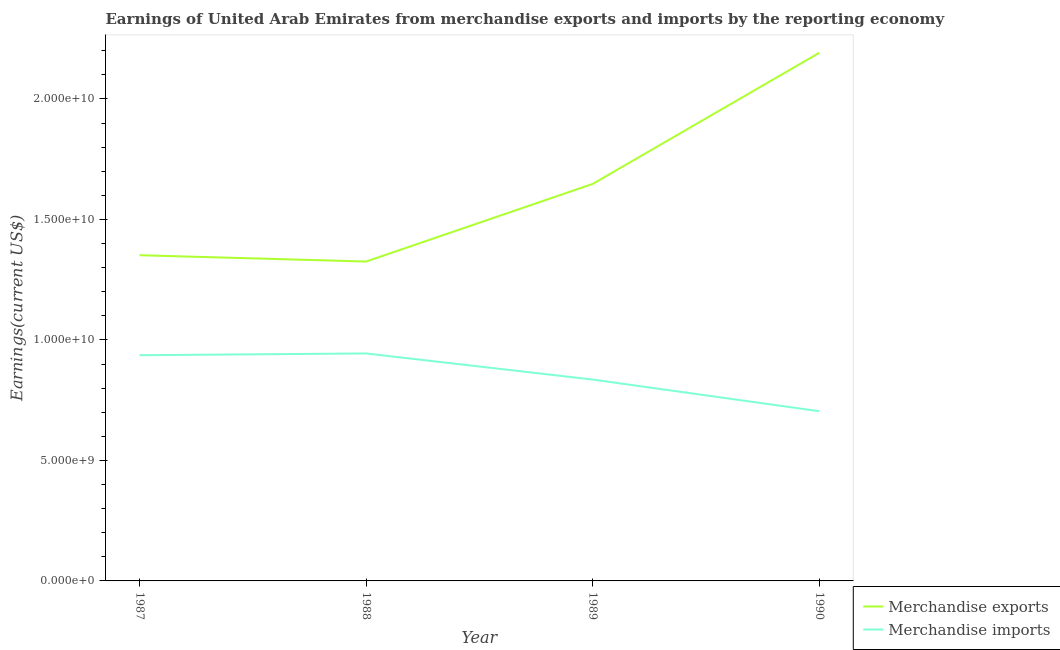Does the line corresponding to earnings from merchandise imports intersect with the line corresponding to earnings from merchandise exports?
Ensure brevity in your answer.  No. What is the earnings from merchandise imports in 1988?
Give a very brief answer. 9.44e+09. Across all years, what is the maximum earnings from merchandise imports?
Offer a very short reply. 9.44e+09. Across all years, what is the minimum earnings from merchandise imports?
Your response must be concise. 7.04e+09. In which year was the earnings from merchandise exports maximum?
Your answer should be compact. 1990. What is the total earnings from merchandise imports in the graph?
Offer a terse response. 3.42e+1. What is the difference between the earnings from merchandise imports in 1987 and that in 1988?
Give a very brief answer. -7.33e+07. What is the difference between the earnings from merchandise exports in 1988 and the earnings from merchandise imports in 1990?
Provide a succinct answer. 6.21e+09. What is the average earnings from merchandise imports per year?
Offer a very short reply. 8.55e+09. In the year 1987, what is the difference between the earnings from merchandise exports and earnings from merchandise imports?
Your answer should be compact. 4.15e+09. In how many years, is the earnings from merchandise exports greater than 9000000000 US$?
Your answer should be compact. 4. What is the ratio of the earnings from merchandise exports in 1987 to that in 1988?
Ensure brevity in your answer.  1.02. Is the difference between the earnings from merchandise exports in 1987 and 1989 greater than the difference between the earnings from merchandise imports in 1987 and 1989?
Offer a very short reply. No. What is the difference between the highest and the second highest earnings from merchandise exports?
Keep it short and to the point. 5.44e+09. What is the difference between the highest and the lowest earnings from merchandise imports?
Give a very brief answer. 2.40e+09. In how many years, is the earnings from merchandise imports greater than the average earnings from merchandise imports taken over all years?
Your answer should be very brief. 2. Does the earnings from merchandise exports monotonically increase over the years?
Offer a very short reply. No. How many lines are there?
Your answer should be very brief. 2. How many years are there in the graph?
Offer a very short reply. 4. Are the values on the major ticks of Y-axis written in scientific E-notation?
Provide a short and direct response. Yes. Does the graph contain grids?
Keep it short and to the point. No. How are the legend labels stacked?
Provide a short and direct response. Vertical. What is the title of the graph?
Make the answer very short. Earnings of United Arab Emirates from merchandise exports and imports by the reporting economy. Does "Borrowers" appear as one of the legend labels in the graph?
Offer a very short reply. No. What is the label or title of the Y-axis?
Ensure brevity in your answer.  Earnings(current US$). What is the Earnings(current US$) of Merchandise exports in 1987?
Ensure brevity in your answer.  1.35e+1. What is the Earnings(current US$) of Merchandise imports in 1987?
Your response must be concise. 9.37e+09. What is the Earnings(current US$) of Merchandise exports in 1988?
Make the answer very short. 1.33e+1. What is the Earnings(current US$) in Merchandise imports in 1988?
Provide a short and direct response. 9.44e+09. What is the Earnings(current US$) in Merchandise exports in 1989?
Provide a short and direct response. 1.65e+1. What is the Earnings(current US$) of Merchandise imports in 1989?
Offer a very short reply. 8.36e+09. What is the Earnings(current US$) of Merchandise exports in 1990?
Make the answer very short. 2.19e+1. What is the Earnings(current US$) in Merchandise imports in 1990?
Ensure brevity in your answer.  7.04e+09. Across all years, what is the maximum Earnings(current US$) in Merchandise exports?
Provide a short and direct response. 2.19e+1. Across all years, what is the maximum Earnings(current US$) of Merchandise imports?
Your response must be concise. 9.44e+09. Across all years, what is the minimum Earnings(current US$) of Merchandise exports?
Keep it short and to the point. 1.33e+1. Across all years, what is the minimum Earnings(current US$) in Merchandise imports?
Offer a very short reply. 7.04e+09. What is the total Earnings(current US$) in Merchandise exports in the graph?
Your answer should be very brief. 6.52e+1. What is the total Earnings(current US$) of Merchandise imports in the graph?
Make the answer very short. 3.42e+1. What is the difference between the Earnings(current US$) of Merchandise exports in 1987 and that in 1988?
Ensure brevity in your answer.  2.62e+08. What is the difference between the Earnings(current US$) in Merchandise imports in 1987 and that in 1988?
Give a very brief answer. -7.33e+07. What is the difference between the Earnings(current US$) of Merchandise exports in 1987 and that in 1989?
Your answer should be very brief. -2.96e+09. What is the difference between the Earnings(current US$) of Merchandise imports in 1987 and that in 1989?
Ensure brevity in your answer.  1.01e+09. What is the difference between the Earnings(current US$) of Merchandise exports in 1987 and that in 1990?
Your answer should be very brief. -8.40e+09. What is the difference between the Earnings(current US$) in Merchandise imports in 1987 and that in 1990?
Offer a very short reply. 2.32e+09. What is the difference between the Earnings(current US$) in Merchandise exports in 1988 and that in 1989?
Make the answer very short. -3.22e+09. What is the difference between the Earnings(current US$) of Merchandise imports in 1988 and that in 1989?
Keep it short and to the point. 1.08e+09. What is the difference between the Earnings(current US$) of Merchandise exports in 1988 and that in 1990?
Offer a terse response. -8.66e+09. What is the difference between the Earnings(current US$) of Merchandise imports in 1988 and that in 1990?
Provide a short and direct response. 2.40e+09. What is the difference between the Earnings(current US$) in Merchandise exports in 1989 and that in 1990?
Provide a succinct answer. -5.44e+09. What is the difference between the Earnings(current US$) of Merchandise imports in 1989 and that in 1990?
Offer a very short reply. 1.31e+09. What is the difference between the Earnings(current US$) in Merchandise exports in 1987 and the Earnings(current US$) in Merchandise imports in 1988?
Offer a terse response. 4.08e+09. What is the difference between the Earnings(current US$) of Merchandise exports in 1987 and the Earnings(current US$) of Merchandise imports in 1989?
Keep it short and to the point. 5.16e+09. What is the difference between the Earnings(current US$) of Merchandise exports in 1987 and the Earnings(current US$) of Merchandise imports in 1990?
Your answer should be very brief. 6.47e+09. What is the difference between the Earnings(current US$) in Merchandise exports in 1988 and the Earnings(current US$) in Merchandise imports in 1989?
Ensure brevity in your answer.  4.90e+09. What is the difference between the Earnings(current US$) in Merchandise exports in 1988 and the Earnings(current US$) in Merchandise imports in 1990?
Make the answer very short. 6.21e+09. What is the difference between the Earnings(current US$) in Merchandise exports in 1989 and the Earnings(current US$) in Merchandise imports in 1990?
Your answer should be very brief. 9.43e+09. What is the average Earnings(current US$) of Merchandise exports per year?
Your answer should be very brief. 1.63e+1. What is the average Earnings(current US$) of Merchandise imports per year?
Provide a succinct answer. 8.55e+09. In the year 1987, what is the difference between the Earnings(current US$) in Merchandise exports and Earnings(current US$) in Merchandise imports?
Your answer should be compact. 4.15e+09. In the year 1988, what is the difference between the Earnings(current US$) of Merchandise exports and Earnings(current US$) of Merchandise imports?
Your answer should be compact. 3.82e+09. In the year 1989, what is the difference between the Earnings(current US$) of Merchandise exports and Earnings(current US$) of Merchandise imports?
Ensure brevity in your answer.  8.12e+09. In the year 1990, what is the difference between the Earnings(current US$) in Merchandise exports and Earnings(current US$) in Merchandise imports?
Make the answer very short. 1.49e+1. What is the ratio of the Earnings(current US$) in Merchandise exports in 1987 to that in 1988?
Keep it short and to the point. 1.02. What is the ratio of the Earnings(current US$) of Merchandise exports in 1987 to that in 1989?
Give a very brief answer. 0.82. What is the ratio of the Earnings(current US$) of Merchandise imports in 1987 to that in 1989?
Keep it short and to the point. 1.12. What is the ratio of the Earnings(current US$) in Merchandise exports in 1987 to that in 1990?
Make the answer very short. 0.62. What is the ratio of the Earnings(current US$) of Merchandise imports in 1987 to that in 1990?
Provide a succinct answer. 1.33. What is the ratio of the Earnings(current US$) of Merchandise exports in 1988 to that in 1989?
Make the answer very short. 0.8. What is the ratio of the Earnings(current US$) of Merchandise imports in 1988 to that in 1989?
Provide a short and direct response. 1.13. What is the ratio of the Earnings(current US$) in Merchandise exports in 1988 to that in 1990?
Offer a terse response. 0.6. What is the ratio of the Earnings(current US$) in Merchandise imports in 1988 to that in 1990?
Give a very brief answer. 1.34. What is the ratio of the Earnings(current US$) of Merchandise exports in 1989 to that in 1990?
Provide a short and direct response. 0.75. What is the ratio of the Earnings(current US$) in Merchandise imports in 1989 to that in 1990?
Offer a very short reply. 1.19. What is the difference between the highest and the second highest Earnings(current US$) of Merchandise exports?
Provide a short and direct response. 5.44e+09. What is the difference between the highest and the second highest Earnings(current US$) in Merchandise imports?
Ensure brevity in your answer.  7.33e+07. What is the difference between the highest and the lowest Earnings(current US$) in Merchandise exports?
Provide a short and direct response. 8.66e+09. What is the difference between the highest and the lowest Earnings(current US$) of Merchandise imports?
Offer a very short reply. 2.40e+09. 